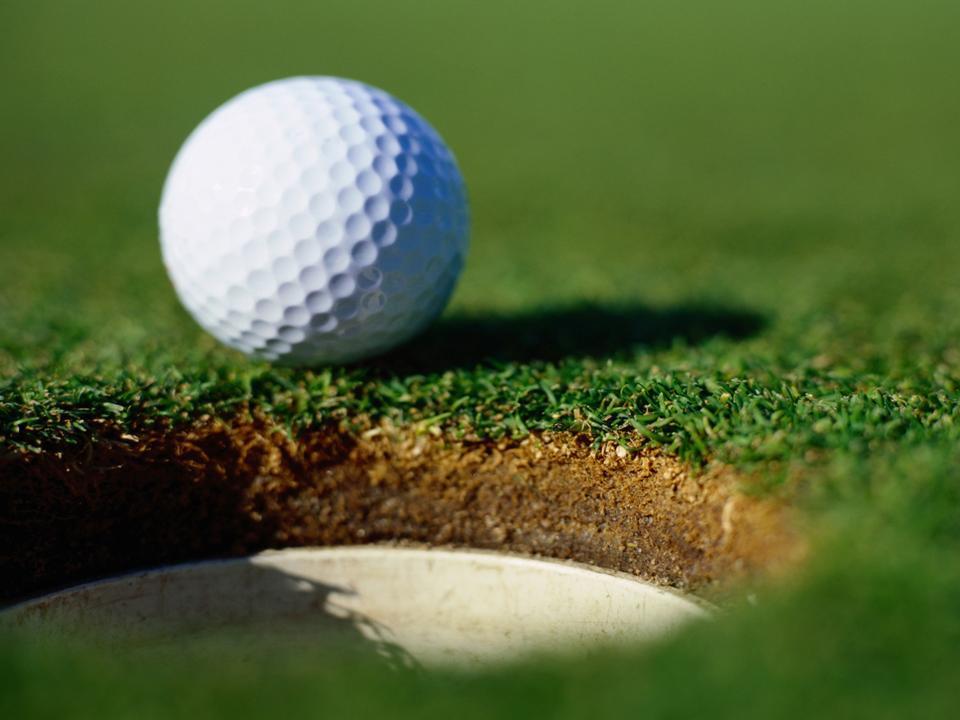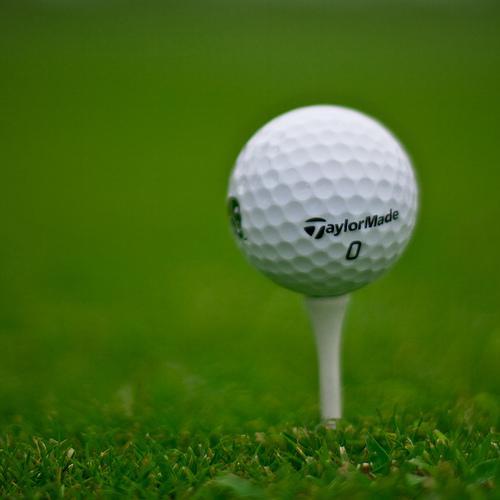The first image is the image on the left, the second image is the image on the right. For the images displayed, is the sentence "One of the images shows a golf ball on the grass." factually correct? Answer yes or no. Yes. 